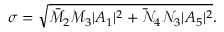Convert formula to latex. <formula><loc_0><loc_0><loc_500><loc_500>\sigma = \sqrt { \bar { \mathcal { M } } _ { 2 } { \mathcal { M } } _ { 3 } | A _ { 1 } | ^ { 2 } + \bar { \mathcal { N } } _ { 4 } { \mathcal { N } } _ { 3 } | A _ { 5 } | ^ { 2 } } .</formula> 